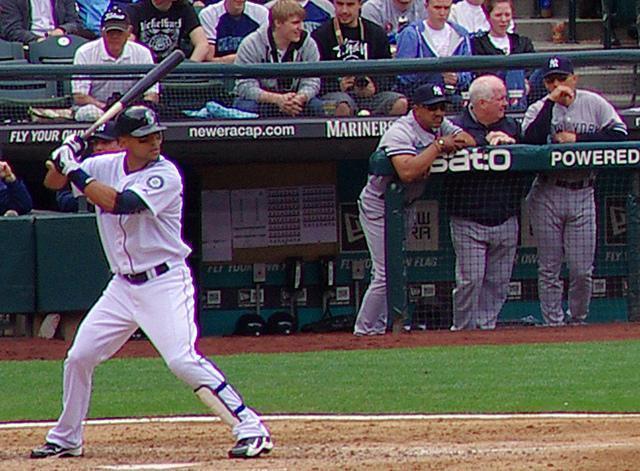How many people are in the picture?
Give a very brief answer. 12. 